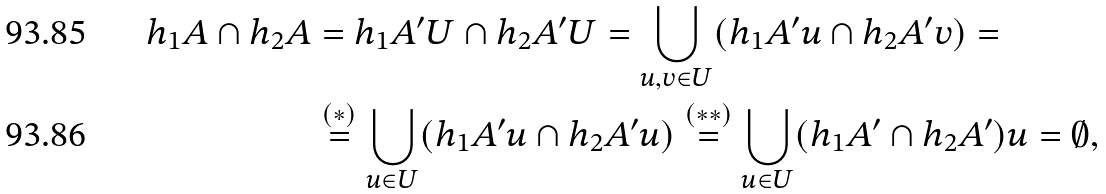Convert formula to latex. <formula><loc_0><loc_0><loc_500><loc_500>h _ { 1 } A \cap h _ { 2 } A & = h _ { 1 } A ^ { \prime } U \cap h _ { 2 } A ^ { \prime } U = \bigcup _ { u , v \in U } ( h _ { 1 } A ^ { \prime } u \cap h _ { 2 } A ^ { \prime } v ) = \\ & \stackrel { ( * ) } { = } \bigcup _ { u \in U } ( h _ { 1 } A ^ { \prime } u \cap h _ { 2 } A ^ { \prime } u ) \stackrel { ( * * ) } { = } \bigcup _ { u \in U } ( h _ { 1 } A ^ { \prime } \cap h _ { 2 } A ^ { \prime } ) u = \emptyset ,</formula> 